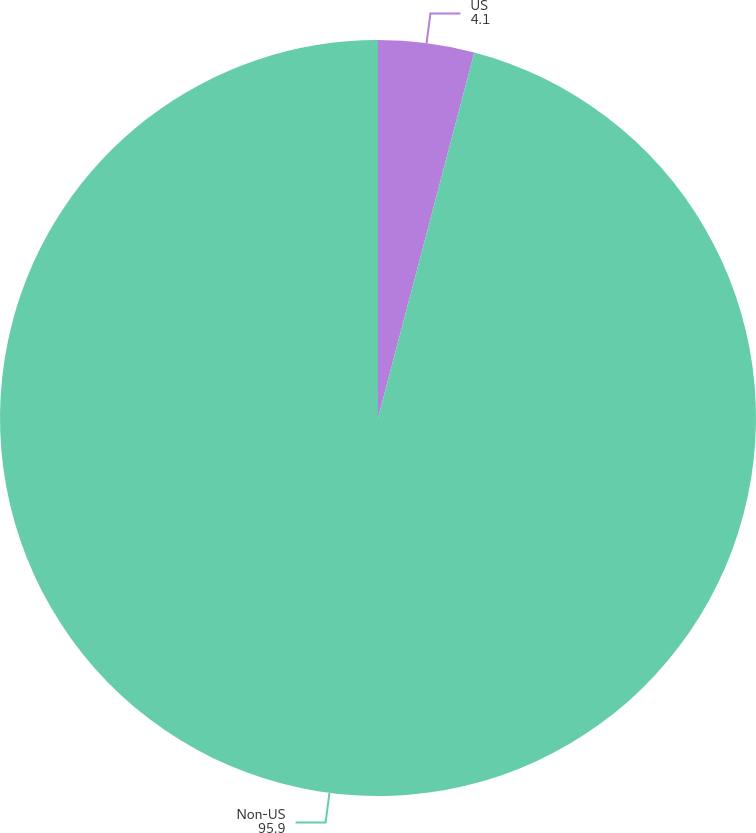Convert chart. <chart><loc_0><loc_0><loc_500><loc_500><pie_chart><fcel>US<fcel>Non-US<nl><fcel>4.1%<fcel>95.9%<nl></chart> 